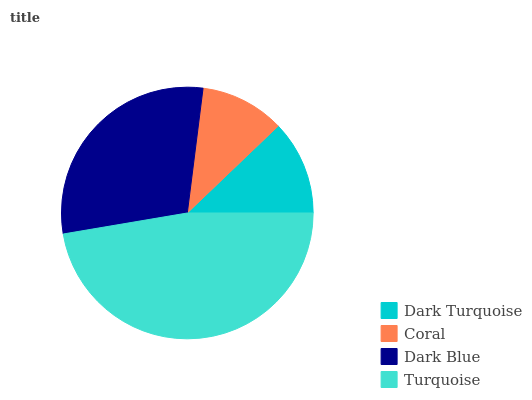Is Coral the minimum?
Answer yes or no. Yes. Is Turquoise the maximum?
Answer yes or no. Yes. Is Dark Blue the minimum?
Answer yes or no. No. Is Dark Blue the maximum?
Answer yes or no. No. Is Dark Blue greater than Coral?
Answer yes or no. Yes. Is Coral less than Dark Blue?
Answer yes or no. Yes. Is Coral greater than Dark Blue?
Answer yes or no. No. Is Dark Blue less than Coral?
Answer yes or no. No. Is Dark Blue the high median?
Answer yes or no. Yes. Is Dark Turquoise the low median?
Answer yes or no. Yes. Is Coral the high median?
Answer yes or no. No. Is Coral the low median?
Answer yes or no. No. 